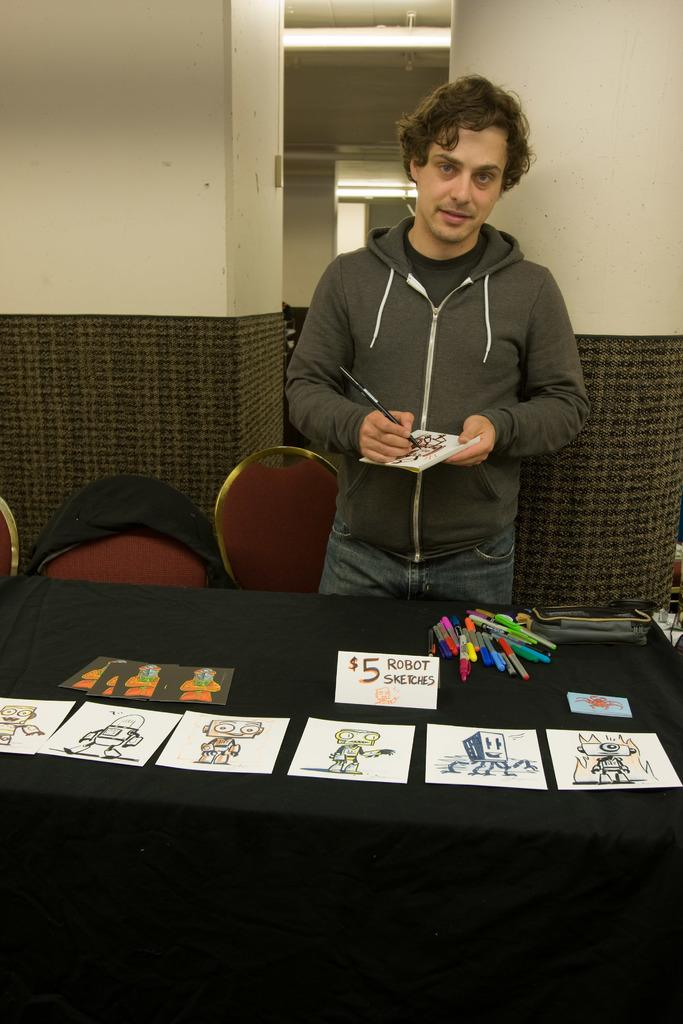What is the man in the image doing? The man is standing and holding a paper and a brush. What objects are present on the table in the image? There are papers and pens on the table. What type of furniture is visible in the image? There are chairs and a table in the image. What type of account is the woman discussing with the man in the image? There is no woman present in the image, so it is not possible to discuss an account with her. 